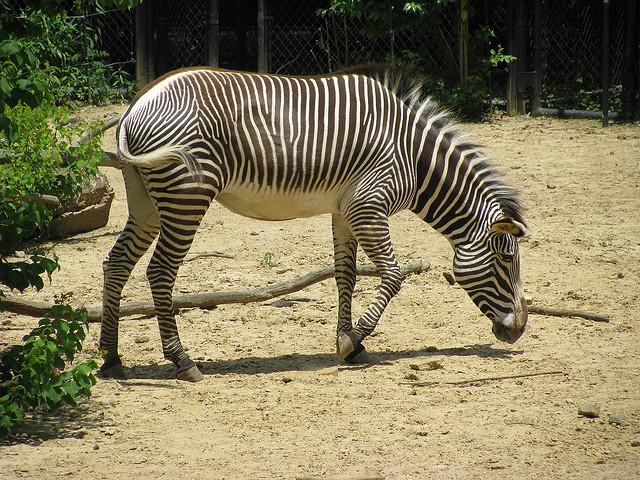How many tails can you see?
Write a very short answer. 1. IS there more than 1 zebra?
Write a very short answer. No. Is this zebra eating dirt?
Be succinct. No. Is the zebra in the shade?
Write a very short answer. No. Is the zebra contained within a fence?
Quick response, please. Yes. 